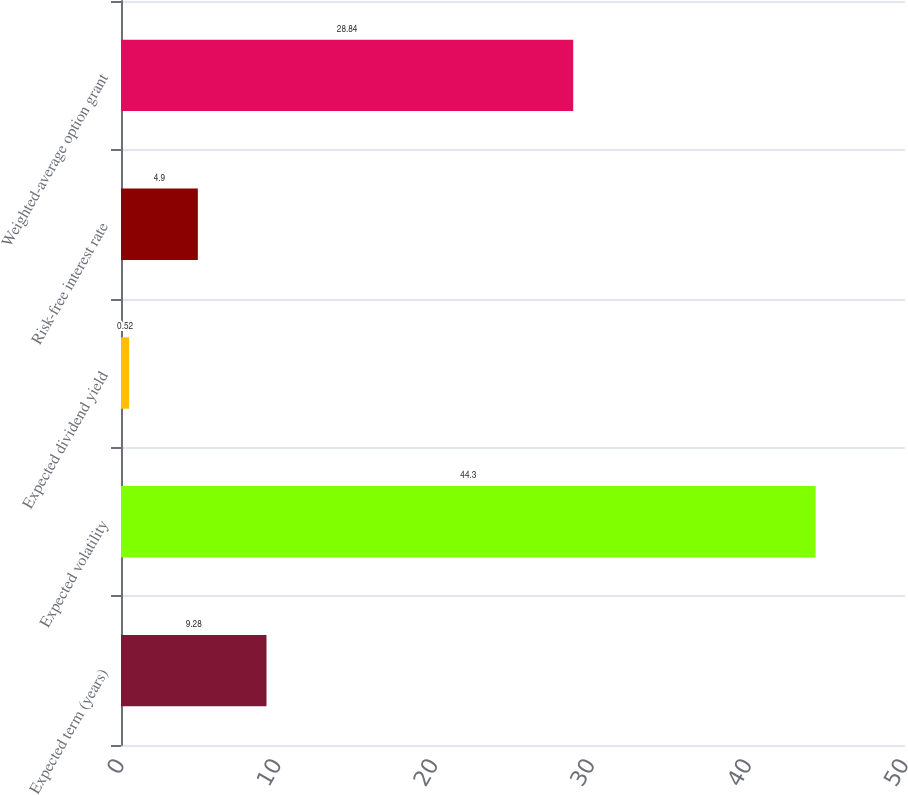Convert chart. <chart><loc_0><loc_0><loc_500><loc_500><bar_chart><fcel>Expected term (years)<fcel>Expected volatility<fcel>Expected dividend yield<fcel>Risk-free interest rate<fcel>Weighted-average option grant<nl><fcel>9.28<fcel>44.3<fcel>0.52<fcel>4.9<fcel>28.84<nl></chart> 